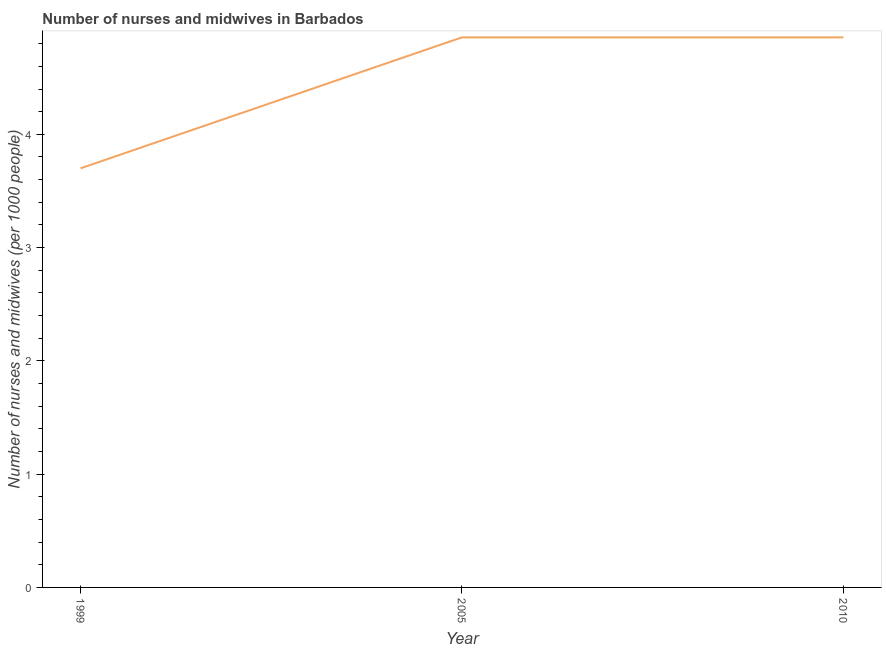What is the number of nurses and midwives in 2010?
Provide a succinct answer. 4.86. Across all years, what is the maximum number of nurses and midwives?
Ensure brevity in your answer.  4.86. Across all years, what is the minimum number of nurses and midwives?
Your answer should be very brief. 3.7. In which year was the number of nurses and midwives maximum?
Your response must be concise. 2005. What is the sum of the number of nurses and midwives?
Provide a succinct answer. 13.41. What is the difference between the number of nurses and midwives in 1999 and 2005?
Ensure brevity in your answer.  -1.16. What is the average number of nurses and midwives per year?
Make the answer very short. 4.47. What is the median number of nurses and midwives?
Give a very brief answer. 4.86. What is the ratio of the number of nurses and midwives in 1999 to that in 2005?
Give a very brief answer. 0.76. Is the difference between the number of nurses and midwives in 1999 and 2010 greater than the difference between any two years?
Make the answer very short. Yes. What is the difference between the highest and the lowest number of nurses and midwives?
Your answer should be compact. 1.16. How many lines are there?
Make the answer very short. 1. What is the difference between two consecutive major ticks on the Y-axis?
Offer a very short reply. 1. Does the graph contain any zero values?
Your answer should be very brief. No. Does the graph contain grids?
Provide a short and direct response. No. What is the title of the graph?
Keep it short and to the point. Number of nurses and midwives in Barbados. What is the label or title of the Y-axis?
Your answer should be very brief. Number of nurses and midwives (per 1000 people). What is the Number of nurses and midwives (per 1000 people) of 1999?
Your answer should be compact. 3.7. What is the Number of nurses and midwives (per 1000 people) of 2005?
Keep it short and to the point. 4.86. What is the Number of nurses and midwives (per 1000 people) of 2010?
Ensure brevity in your answer.  4.86. What is the difference between the Number of nurses and midwives (per 1000 people) in 1999 and 2005?
Ensure brevity in your answer.  -1.16. What is the difference between the Number of nurses and midwives (per 1000 people) in 1999 and 2010?
Give a very brief answer. -1.16. What is the difference between the Number of nurses and midwives (per 1000 people) in 2005 and 2010?
Make the answer very short. 0. What is the ratio of the Number of nurses and midwives (per 1000 people) in 1999 to that in 2005?
Provide a succinct answer. 0.76. What is the ratio of the Number of nurses and midwives (per 1000 people) in 1999 to that in 2010?
Your answer should be very brief. 0.76. What is the ratio of the Number of nurses and midwives (per 1000 people) in 2005 to that in 2010?
Your answer should be very brief. 1. 